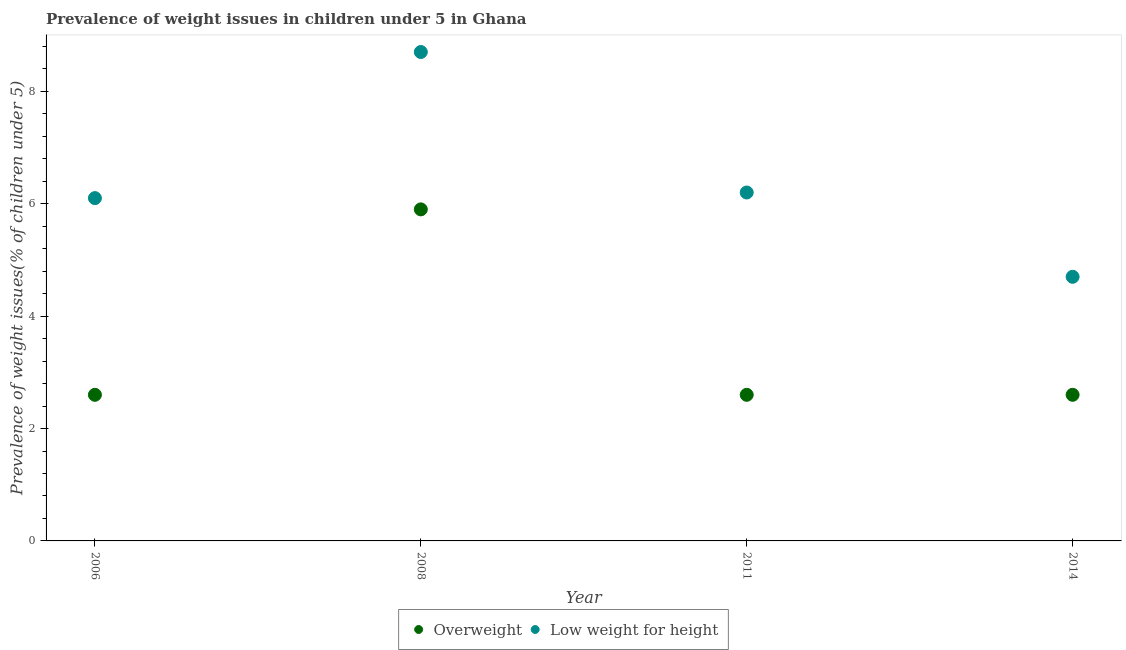What is the percentage of overweight children in 2014?
Your answer should be compact. 2.6. Across all years, what is the maximum percentage of overweight children?
Offer a terse response. 5.9. Across all years, what is the minimum percentage of underweight children?
Provide a short and direct response. 4.7. What is the total percentage of overweight children in the graph?
Your answer should be very brief. 13.7. What is the difference between the percentage of overweight children in 2014 and the percentage of underweight children in 2008?
Offer a very short reply. -6.1. What is the average percentage of overweight children per year?
Offer a very short reply. 3.42. In the year 2008, what is the difference between the percentage of overweight children and percentage of underweight children?
Provide a short and direct response. -2.8. What is the ratio of the percentage of overweight children in 2011 to that in 2014?
Make the answer very short. 1. Is the difference between the percentage of underweight children in 2011 and 2014 greater than the difference between the percentage of overweight children in 2011 and 2014?
Keep it short and to the point. Yes. What is the difference between the highest and the second highest percentage of underweight children?
Your answer should be compact. 2.5. What is the difference between the highest and the lowest percentage of overweight children?
Ensure brevity in your answer.  3.3. Is the sum of the percentage of overweight children in 2006 and 2014 greater than the maximum percentage of underweight children across all years?
Provide a succinct answer. No. Does the graph contain any zero values?
Your response must be concise. No. Does the graph contain grids?
Make the answer very short. No. How are the legend labels stacked?
Give a very brief answer. Horizontal. What is the title of the graph?
Make the answer very short. Prevalence of weight issues in children under 5 in Ghana. What is the label or title of the Y-axis?
Keep it short and to the point. Prevalence of weight issues(% of children under 5). What is the Prevalence of weight issues(% of children under 5) in Overweight in 2006?
Make the answer very short. 2.6. What is the Prevalence of weight issues(% of children under 5) in Low weight for height in 2006?
Your answer should be very brief. 6.1. What is the Prevalence of weight issues(% of children under 5) of Overweight in 2008?
Your answer should be compact. 5.9. What is the Prevalence of weight issues(% of children under 5) in Low weight for height in 2008?
Provide a short and direct response. 8.7. What is the Prevalence of weight issues(% of children under 5) of Overweight in 2011?
Give a very brief answer. 2.6. What is the Prevalence of weight issues(% of children under 5) in Low weight for height in 2011?
Provide a succinct answer. 6.2. What is the Prevalence of weight issues(% of children under 5) of Overweight in 2014?
Offer a terse response. 2.6. What is the Prevalence of weight issues(% of children under 5) of Low weight for height in 2014?
Offer a terse response. 4.7. Across all years, what is the maximum Prevalence of weight issues(% of children under 5) in Overweight?
Provide a succinct answer. 5.9. Across all years, what is the maximum Prevalence of weight issues(% of children under 5) in Low weight for height?
Keep it short and to the point. 8.7. Across all years, what is the minimum Prevalence of weight issues(% of children under 5) of Overweight?
Provide a short and direct response. 2.6. Across all years, what is the minimum Prevalence of weight issues(% of children under 5) in Low weight for height?
Your answer should be compact. 4.7. What is the total Prevalence of weight issues(% of children under 5) of Low weight for height in the graph?
Your response must be concise. 25.7. What is the difference between the Prevalence of weight issues(% of children under 5) of Overweight in 2008 and that in 2011?
Offer a very short reply. 3.3. What is the difference between the Prevalence of weight issues(% of children under 5) of Overweight in 2008 and that in 2014?
Provide a short and direct response. 3.3. What is the difference between the Prevalence of weight issues(% of children under 5) of Low weight for height in 2008 and that in 2014?
Your response must be concise. 4. What is the difference between the Prevalence of weight issues(% of children under 5) in Overweight in 2011 and that in 2014?
Your answer should be very brief. 0. What is the difference between the Prevalence of weight issues(% of children under 5) of Overweight in 2006 and the Prevalence of weight issues(% of children under 5) of Low weight for height in 2011?
Offer a terse response. -3.6. What is the difference between the Prevalence of weight issues(% of children under 5) of Overweight in 2008 and the Prevalence of weight issues(% of children under 5) of Low weight for height in 2011?
Give a very brief answer. -0.3. What is the difference between the Prevalence of weight issues(% of children under 5) of Overweight in 2008 and the Prevalence of weight issues(% of children under 5) of Low weight for height in 2014?
Your answer should be compact. 1.2. What is the difference between the Prevalence of weight issues(% of children under 5) of Overweight in 2011 and the Prevalence of weight issues(% of children under 5) of Low weight for height in 2014?
Ensure brevity in your answer.  -2.1. What is the average Prevalence of weight issues(% of children under 5) of Overweight per year?
Your answer should be compact. 3.42. What is the average Prevalence of weight issues(% of children under 5) of Low weight for height per year?
Give a very brief answer. 6.42. In the year 2006, what is the difference between the Prevalence of weight issues(% of children under 5) of Overweight and Prevalence of weight issues(% of children under 5) of Low weight for height?
Ensure brevity in your answer.  -3.5. In the year 2008, what is the difference between the Prevalence of weight issues(% of children under 5) of Overweight and Prevalence of weight issues(% of children under 5) of Low weight for height?
Offer a terse response. -2.8. What is the ratio of the Prevalence of weight issues(% of children under 5) in Overweight in 2006 to that in 2008?
Offer a terse response. 0.44. What is the ratio of the Prevalence of weight issues(% of children under 5) in Low weight for height in 2006 to that in 2008?
Your answer should be compact. 0.7. What is the ratio of the Prevalence of weight issues(% of children under 5) in Low weight for height in 2006 to that in 2011?
Offer a very short reply. 0.98. What is the ratio of the Prevalence of weight issues(% of children under 5) in Low weight for height in 2006 to that in 2014?
Provide a succinct answer. 1.3. What is the ratio of the Prevalence of weight issues(% of children under 5) in Overweight in 2008 to that in 2011?
Your response must be concise. 2.27. What is the ratio of the Prevalence of weight issues(% of children under 5) in Low weight for height in 2008 to that in 2011?
Your answer should be very brief. 1.4. What is the ratio of the Prevalence of weight issues(% of children under 5) of Overweight in 2008 to that in 2014?
Keep it short and to the point. 2.27. What is the ratio of the Prevalence of weight issues(% of children under 5) of Low weight for height in 2008 to that in 2014?
Keep it short and to the point. 1.85. What is the ratio of the Prevalence of weight issues(% of children under 5) in Overweight in 2011 to that in 2014?
Your answer should be compact. 1. What is the ratio of the Prevalence of weight issues(% of children under 5) of Low weight for height in 2011 to that in 2014?
Provide a short and direct response. 1.32. What is the difference between the highest and the second highest Prevalence of weight issues(% of children under 5) of Overweight?
Your response must be concise. 3.3. What is the difference between the highest and the second highest Prevalence of weight issues(% of children under 5) in Low weight for height?
Make the answer very short. 2.5. 